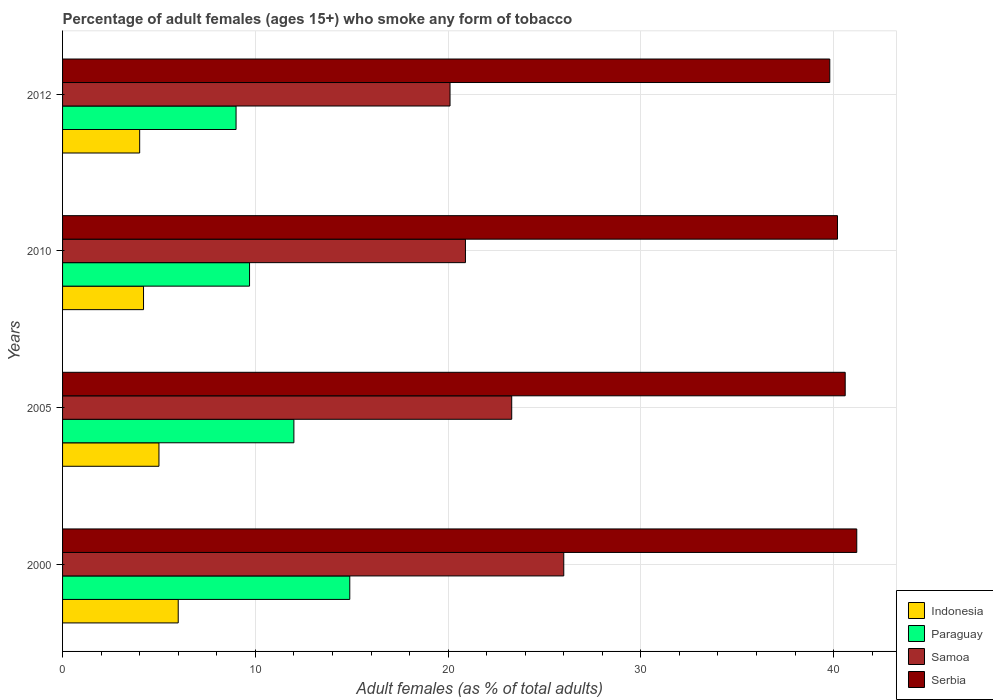How many groups of bars are there?
Make the answer very short. 4. How many bars are there on the 2nd tick from the bottom?
Keep it short and to the point. 4. What is the percentage of adult females who smoke in Indonesia in 2012?
Give a very brief answer. 4. Across all years, what is the minimum percentage of adult females who smoke in Paraguay?
Ensure brevity in your answer.  9. In which year was the percentage of adult females who smoke in Indonesia maximum?
Your answer should be compact. 2000. What is the total percentage of adult females who smoke in Indonesia in the graph?
Offer a very short reply. 19.2. What is the difference between the percentage of adult females who smoke in Serbia in 2010 and that in 2012?
Offer a terse response. 0.4. What is the difference between the percentage of adult females who smoke in Indonesia in 2010 and the percentage of adult females who smoke in Samoa in 2000?
Your answer should be compact. -21.8. What is the average percentage of adult females who smoke in Paraguay per year?
Give a very brief answer. 11.4. In the year 2012, what is the difference between the percentage of adult females who smoke in Paraguay and percentage of adult females who smoke in Serbia?
Provide a short and direct response. -30.8. In how many years, is the percentage of adult females who smoke in Indonesia greater than 2 %?
Ensure brevity in your answer.  4. What is the ratio of the percentage of adult females who smoke in Indonesia in 2000 to that in 2005?
Provide a succinct answer. 1.2. Is the percentage of adult females who smoke in Indonesia in 2000 less than that in 2012?
Make the answer very short. No. What is the difference between the highest and the second highest percentage of adult females who smoke in Samoa?
Offer a very short reply. 2.7. Is the sum of the percentage of adult females who smoke in Samoa in 2000 and 2012 greater than the maximum percentage of adult females who smoke in Paraguay across all years?
Keep it short and to the point. Yes. Is it the case that in every year, the sum of the percentage of adult females who smoke in Indonesia and percentage of adult females who smoke in Serbia is greater than the sum of percentage of adult females who smoke in Samoa and percentage of adult females who smoke in Paraguay?
Give a very brief answer. No. What does the 3rd bar from the top in 2005 represents?
Offer a very short reply. Paraguay. What does the 3rd bar from the bottom in 2005 represents?
Offer a very short reply. Samoa. How many bars are there?
Your response must be concise. 16. Are all the bars in the graph horizontal?
Offer a very short reply. Yes. Are the values on the major ticks of X-axis written in scientific E-notation?
Keep it short and to the point. No. Does the graph contain grids?
Ensure brevity in your answer.  Yes. Where does the legend appear in the graph?
Give a very brief answer. Bottom right. How many legend labels are there?
Keep it short and to the point. 4. What is the title of the graph?
Provide a short and direct response. Percentage of adult females (ages 15+) who smoke any form of tobacco. Does "Slovak Republic" appear as one of the legend labels in the graph?
Offer a terse response. No. What is the label or title of the X-axis?
Make the answer very short. Adult females (as % of total adults). What is the Adult females (as % of total adults) in Serbia in 2000?
Your answer should be very brief. 41.2. What is the Adult females (as % of total adults) in Samoa in 2005?
Ensure brevity in your answer.  23.3. What is the Adult females (as % of total adults) of Serbia in 2005?
Make the answer very short. 40.6. What is the Adult females (as % of total adults) of Indonesia in 2010?
Provide a short and direct response. 4.2. What is the Adult females (as % of total adults) of Paraguay in 2010?
Your answer should be very brief. 9.7. What is the Adult females (as % of total adults) of Samoa in 2010?
Your response must be concise. 20.9. What is the Adult females (as % of total adults) of Serbia in 2010?
Keep it short and to the point. 40.2. What is the Adult females (as % of total adults) in Samoa in 2012?
Give a very brief answer. 20.1. What is the Adult females (as % of total adults) in Serbia in 2012?
Your response must be concise. 39.8. Across all years, what is the maximum Adult females (as % of total adults) in Samoa?
Offer a terse response. 26. Across all years, what is the maximum Adult females (as % of total adults) of Serbia?
Offer a very short reply. 41.2. Across all years, what is the minimum Adult females (as % of total adults) in Indonesia?
Keep it short and to the point. 4. Across all years, what is the minimum Adult females (as % of total adults) of Samoa?
Your response must be concise. 20.1. Across all years, what is the minimum Adult females (as % of total adults) of Serbia?
Your answer should be compact. 39.8. What is the total Adult females (as % of total adults) in Indonesia in the graph?
Give a very brief answer. 19.2. What is the total Adult females (as % of total adults) in Paraguay in the graph?
Make the answer very short. 45.6. What is the total Adult females (as % of total adults) in Samoa in the graph?
Your answer should be very brief. 90.3. What is the total Adult females (as % of total adults) of Serbia in the graph?
Your answer should be compact. 161.8. What is the difference between the Adult females (as % of total adults) of Indonesia in 2000 and that in 2010?
Offer a very short reply. 1.8. What is the difference between the Adult females (as % of total adults) in Serbia in 2000 and that in 2010?
Ensure brevity in your answer.  1. What is the difference between the Adult females (as % of total adults) of Paraguay in 2000 and that in 2012?
Ensure brevity in your answer.  5.9. What is the difference between the Adult females (as % of total adults) of Serbia in 2000 and that in 2012?
Give a very brief answer. 1.4. What is the difference between the Adult females (as % of total adults) in Samoa in 2005 and that in 2010?
Offer a very short reply. 2.4. What is the difference between the Adult females (as % of total adults) of Indonesia in 2010 and that in 2012?
Offer a very short reply. 0.2. What is the difference between the Adult females (as % of total adults) in Samoa in 2010 and that in 2012?
Provide a succinct answer. 0.8. What is the difference between the Adult females (as % of total adults) of Indonesia in 2000 and the Adult females (as % of total adults) of Samoa in 2005?
Ensure brevity in your answer.  -17.3. What is the difference between the Adult females (as % of total adults) of Indonesia in 2000 and the Adult females (as % of total adults) of Serbia in 2005?
Offer a terse response. -34.6. What is the difference between the Adult females (as % of total adults) of Paraguay in 2000 and the Adult females (as % of total adults) of Serbia in 2005?
Make the answer very short. -25.7. What is the difference between the Adult females (as % of total adults) of Samoa in 2000 and the Adult females (as % of total adults) of Serbia in 2005?
Provide a short and direct response. -14.6. What is the difference between the Adult females (as % of total adults) in Indonesia in 2000 and the Adult females (as % of total adults) in Samoa in 2010?
Provide a short and direct response. -14.9. What is the difference between the Adult females (as % of total adults) of Indonesia in 2000 and the Adult females (as % of total adults) of Serbia in 2010?
Your response must be concise. -34.2. What is the difference between the Adult females (as % of total adults) in Paraguay in 2000 and the Adult females (as % of total adults) in Samoa in 2010?
Give a very brief answer. -6. What is the difference between the Adult females (as % of total adults) in Paraguay in 2000 and the Adult females (as % of total adults) in Serbia in 2010?
Offer a terse response. -25.3. What is the difference between the Adult females (as % of total adults) of Samoa in 2000 and the Adult females (as % of total adults) of Serbia in 2010?
Provide a short and direct response. -14.2. What is the difference between the Adult females (as % of total adults) in Indonesia in 2000 and the Adult females (as % of total adults) in Samoa in 2012?
Provide a short and direct response. -14.1. What is the difference between the Adult females (as % of total adults) in Indonesia in 2000 and the Adult females (as % of total adults) in Serbia in 2012?
Give a very brief answer. -33.8. What is the difference between the Adult females (as % of total adults) of Paraguay in 2000 and the Adult females (as % of total adults) of Serbia in 2012?
Your answer should be very brief. -24.9. What is the difference between the Adult females (as % of total adults) of Indonesia in 2005 and the Adult females (as % of total adults) of Paraguay in 2010?
Provide a succinct answer. -4.7. What is the difference between the Adult females (as % of total adults) of Indonesia in 2005 and the Adult females (as % of total adults) of Samoa in 2010?
Ensure brevity in your answer.  -15.9. What is the difference between the Adult females (as % of total adults) of Indonesia in 2005 and the Adult females (as % of total adults) of Serbia in 2010?
Offer a terse response. -35.2. What is the difference between the Adult females (as % of total adults) in Paraguay in 2005 and the Adult females (as % of total adults) in Serbia in 2010?
Make the answer very short. -28.2. What is the difference between the Adult females (as % of total adults) in Samoa in 2005 and the Adult females (as % of total adults) in Serbia in 2010?
Your answer should be very brief. -16.9. What is the difference between the Adult females (as % of total adults) of Indonesia in 2005 and the Adult females (as % of total adults) of Samoa in 2012?
Offer a very short reply. -15.1. What is the difference between the Adult females (as % of total adults) in Indonesia in 2005 and the Adult females (as % of total adults) in Serbia in 2012?
Provide a short and direct response. -34.8. What is the difference between the Adult females (as % of total adults) of Paraguay in 2005 and the Adult females (as % of total adults) of Serbia in 2012?
Provide a succinct answer. -27.8. What is the difference between the Adult females (as % of total adults) of Samoa in 2005 and the Adult females (as % of total adults) of Serbia in 2012?
Make the answer very short. -16.5. What is the difference between the Adult females (as % of total adults) in Indonesia in 2010 and the Adult females (as % of total adults) in Samoa in 2012?
Offer a very short reply. -15.9. What is the difference between the Adult females (as % of total adults) in Indonesia in 2010 and the Adult females (as % of total adults) in Serbia in 2012?
Your response must be concise. -35.6. What is the difference between the Adult females (as % of total adults) in Paraguay in 2010 and the Adult females (as % of total adults) in Samoa in 2012?
Provide a short and direct response. -10.4. What is the difference between the Adult females (as % of total adults) of Paraguay in 2010 and the Adult females (as % of total adults) of Serbia in 2012?
Your answer should be very brief. -30.1. What is the difference between the Adult females (as % of total adults) in Samoa in 2010 and the Adult females (as % of total adults) in Serbia in 2012?
Offer a very short reply. -18.9. What is the average Adult females (as % of total adults) in Indonesia per year?
Provide a succinct answer. 4.8. What is the average Adult females (as % of total adults) in Samoa per year?
Provide a succinct answer. 22.57. What is the average Adult females (as % of total adults) of Serbia per year?
Offer a terse response. 40.45. In the year 2000, what is the difference between the Adult females (as % of total adults) of Indonesia and Adult females (as % of total adults) of Paraguay?
Keep it short and to the point. -8.9. In the year 2000, what is the difference between the Adult females (as % of total adults) in Indonesia and Adult females (as % of total adults) in Serbia?
Give a very brief answer. -35.2. In the year 2000, what is the difference between the Adult females (as % of total adults) of Paraguay and Adult females (as % of total adults) of Serbia?
Provide a short and direct response. -26.3. In the year 2000, what is the difference between the Adult females (as % of total adults) in Samoa and Adult females (as % of total adults) in Serbia?
Keep it short and to the point. -15.2. In the year 2005, what is the difference between the Adult females (as % of total adults) in Indonesia and Adult females (as % of total adults) in Samoa?
Keep it short and to the point. -18.3. In the year 2005, what is the difference between the Adult females (as % of total adults) of Indonesia and Adult females (as % of total adults) of Serbia?
Your answer should be compact. -35.6. In the year 2005, what is the difference between the Adult females (as % of total adults) in Paraguay and Adult females (as % of total adults) in Samoa?
Make the answer very short. -11.3. In the year 2005, what is the difference between the Adult females (as % of total adults) in Paraguay and Adult females (as % of total adults) in Serbia?
Provide a succinct answer. -28.6. In the year 2005, what is the difference between the Adult females (as % of total adults) of Samoa and Adult females (as % of total adults) of Serbia?
Keep it short and to the point. -17.3. In the year 2010, what is the difference between the Adult females (as % of total adults) of Indonesia and Adult females (as % of total adults) of Samoa?
Your answer should be compact. -16.7. In the year 2010, what is the difference between the Adult females (as % of total adults) of Indonesia and Adult females (as % of total adults) of Serbia?
Keep it short and to the point. -36. In the year 2010, what is the difference between the Adult females (as % of total adults) in Paraguay and Adult females (as % of total adults) in Serbia?
Make the answer very short. -30.5. In the year 2010, what is the difference between the Adult females (as % of total adults) in Samoa and Adult females (as % of total adults) in Serbia?
Your response must be concise. -19.3. In the year 2012, what is the difference between the Adult females (as % of total adults) of Indonesia and Adult females (as % of total adults) of Samoa?
Provide a short and direct response. -16.1. In the year 2012, what is the difference between the Adult females (as % of total adults) of Indonesia and Adult females (as % of total adults) of Serbia?
Offer a terse response. -35.8. In the year 2012, what is the difference between the Adult females (as % of total adults) of Paraguay and Adult females (as % of total adults) of Samoa?
Offer a terse response. -11.1. In the year 2012, what is the difference between the Adult females (as % of total adults) in Paraguay and Adult females (as % of total adults) in Serbia?
Offer a terse response. -30.8. In the year 2012, what is the difference between the Adult females (as % of total adults) in Samoa and Adult females (as % of total adults) in Serbia?
Provide a short and direct response. -19.7. What is the ratio of the Adult females (as % of total adults) of Indonesia in 2000 to that in 2005?
Give a very brief answer. 1.2. What is the ratio of the Adult females (as % of total adults) in Paraguay in 2000 to that in 2005?
Provide a succinct answer. 1.24. What is the ratio of the Adult females (as % of total adults) of Samoa in 2000 to that in 2005?
Keep it short and to the point. 1.12. What is the ratio of the Adult females (as % of total adults) of Serbia in 2000 to that in 2005?
Provide a succinct answer. 1.01. What is the ratio of the Adult females (as % of total adults) in Indonesia in 2000 to that in 2010?
Ensure brevity in your answer.  1.43. What is the ratio of the Adult females (as % of total adults) in Paraguay in 2000 to that in 2010?
Offer a terse response. 1.54. What is the ratio of the Adult females (as % of total adults) in Samoa in 2000 to that in 2010?
Provide a short and direct response. 1.24. What is the ratio of the Adult females (as % of total adults) of Serbia in 2000 to that in 2010?
Provide a succinct answer. 1.02. What is the ratio of the Adult females (as % of total adults) of Indonesia in 2000 to that in 2012?
Offer a very short reply. 1.5. What is the ratio of the Adult females (as % of total adults) in Paraguay in 2000 to that in 2012?
Provide a succinct answer. 1.66. What is the ratio of the Adult females (as % of total adults) in Samoa in 2000 to that in 2012?
Offer a terse response. 1.29. What is the ratio of the Adult females (as % of total adults) of Serbia in 2000 to that in 2012?
Ensure brevity in your answer.  1.04. What is the ratio of the Adult females (as % of total adults) of Indonesia in 2005 to that in 2010?
Ensure brevity in your answer.  1.19. What is the ratio of the Adult females (as % of total adults) of Paraguay in 2005 to that in 2010?
Give a very brief answer. 1.24. What is the ratio of the Adult females (as % of total adults) of Samoa in 2005 to that in 2010?
Your response must be concise. 1.11. What is the ratio of the Adult females (as % of total adults) of Paraguay in 2005 to that in 2012?
Your answer should be very brief. 1.33. What is the ratio of the Adult females (as % of total adults) in Samoa in 2005 to that in 2012?
Give a very brief answer. 1.16. What is the ratio of the Adult females (as % of total adults) of Serbia in 2005 to that in 2012?
Provide a succinct answer. 1.02. What is the ratio of the Adult females (as % of total adults) of Indonesia in 2010 to that in 2012?
Your response must be concise. 1.05. What is the ratio of the Adult females (as % of total adults) in Paraguay in 2010 to that in 2012?
Make the answer very short. 1.08. What is the ratio of the Adult females (as % of total adults) in Samoa in 2010 to that in 2012?
Make the answer very short. 1.04. What is the difference between the highest and the second highest Adult females (as % of total adults) of Indonesia?
Offer a terse response. 1. What is the difference between the highest and the lowest Adult females (as % of total adults) of Paraguay?
Make the answer very short. 5.9. 